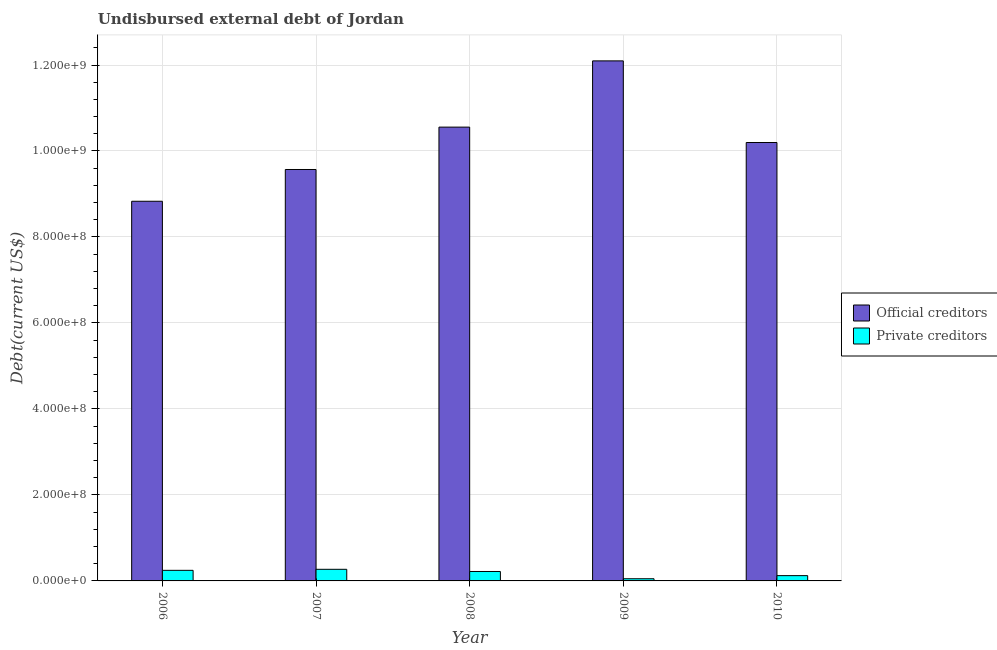How many different coloured bars are there?
Your answer should be compact. 2. How many bars are there on the 3rd tick from the right?
Keep it short and to the point. 2. What is the undisbursed external debt of official creditors in 2009?
Offer a very short reply. 1.21e+09. Across all years, what is the maximum undisbursed external debt of private creditors?
Make the answer very short. 2.70e+07. Across all years, what is the minimum undisbursed external debt of private creditors?
Provide a succinct answer. 5.06e+06. In which year was the undisbursed external debt of private creditors maximum?
Your answer should be very brief. 2007. What is the total undisbursed external debt of private creditors in the graph?
Keep it short and to the point. 9.10e+07. What is the difference between the undisbursed external debt of private creditors in 2008 and that in 2009?
Offer a very short reply. 1.69e+07. What is the difference between the undisbursed external debt of official creditors in 2009 and the undisbursed external debt of private creditors in 2008?
Your answer should be very brief. 1.54e+08. What is the average undisbursed external debt of private creditors per year?
Your answer should be very brief. 1.82e+07. What is the ratio of the undisbursed external debt of official creditors in 2006 to that in 2008?
Provide a short and direct response. 0.84. What is the difference between the highest and the second highest undisbursed external debt of private creditors?
Your answer should be very brief. 2.39e+06. What is the difference between the highest and the lowest undisbursed external debt of private creditors?
Make the answer very short. 2.20e+07. What does the 1st bar from the left in 2008 represents?
Ensure brevity in your answer.  Official creditors. What does the 1st bar from the right in 2006 represents?
Give a very brief answer. Private creditors. How many bars are there?
Your answer should be very brief. 10. What is the difference between two consecutive major ticks on the Y-axis?
Your answer should be compact. 2.00e+08. Are the values on the major ticks of Y-axis written in scientific E-notation?
Provide a short and direct response. Yes. Does the graph contain any zero values?
Your response must be concise. No. Does the graph contain grids?
Ensure brevity in your answer.  Yes. Where does the legend appear in the graph?
Keep it short and to the point. Center right. How many legend labels are there?
Keep it short and to the point. 2. How are the legend labels stacked?
Offer a very short reply. Vertical. What is the title of the graph?
Give a very brief answer. Undisbursed external debt of Jordan. Does "Passenger Transport Items" appear as one of the legend labels in the graph?
Make the answer very short. No. What is the label or title of the Y-axis?
Offer a terse response. Debt(current US$). What is the Debt(current US$) in Official creditors in 2006?
Offer a terse response. 8.83e+08. What is the Debt(current US$) of Private creditors in 2006?
Provide a succinct answer. 2.46e+07. What is the Debt(current US$) of Official creditors in 2007?
Provide a succinct answer. 9.57e+08. What is the Debt(current US$) in Private creditors in 2007?
Offer a very short reply. 2.70e+07. What is the Debt(current US$) in Official creditors in 2008?
Your response must be concise. 1.06e+09. What is the Debt(current US$) of Private creditors in 2008?
Keep it short and to the point. 2.19e+07. What is the Debt(current US$) of Official creditors in 2009?
Keep it short and to the point. 1.21e+09. What is the Debt(current US$) of Private creditors in 2009?
Make the answer very short. 5.06e+06. What is the Debt(current US$) in Official creditors in 2010?
Your response must be concise. 1.02e+09. What is the Debt(current US$) of Private creditors in 2010?
Your answer should be compact. 1.23e+07. Across all years, what is the maximum Debt(current US$) of Official creditors?
Offer a very short reply. 1.21e+09. Across all years, what is the maximum Debt(current US$) of Private creditors?
Provide a succinct answer. 2.70e+07. Across all years, what is the minimum Debt(current US$) of Official creditors?
Offer a terse response. 8.83e+08. Across all years, what is the minimum Debt(current US$) in Private creditors?
Provide a succinct answer. 5.06e+06. What is the total Debt(current US$) of Official creditors in the graph?
Keep it short and to the point. 5.12e+09. What is the total Debt(current US$) of Private creditors in the graph?
Make the answer very short. 9.10e+07. What is the difference between the Debt(current US$) of Official creditors in 2006 and that in 2007?
Give a very brief answer. -7.39e+07. What is the difference between the Debt(current US$) of Private creditors in 2006 and that in 2007?
Offer a very short reply. -2.39e+06. What is the difference between the Debt(current US$) of Official creditors in 2006 and that in 2008?
Your response must be concise. -1.72e+08. What is the difference between the Debt(current US$) in Private creditors in 2006 and that in 2008?
Ensure brevity in your answer.  2.71e+06. What is the difference between the Debt(current US$) in Official creditors in 2006 and that in 2009?
Ensure brevity in your answer.  -3.27e+08. What is the difference between the Debt(current US$) of Private creditors in 2006 and that in 2009?
Keep it short and to the point. 1.96e+07. What is the difference between the Debt(current US$) of Official creditors in 2006 and that in 2010?
Provide a succinct answer. -1.37e+08. What is the difference between the Debt(current US$) of Private creditors in 2006 and that in 2010?
Make the answer very short. 1.23e+07. What is the difference between the Debt(current US$) in Official creditors in 2007 and that in 2008?
Offer a terse response. -9.86e+07. What is the difference between the Debt(current US$) of Private creditors in 2007 and that in 2008?
Your answer should be compact. 5.10e+06. What is the difference between the Debt(current US$) of Official creditors in 2007 and that in 2009?
Ensure brevity in your answer.  -2.53e+08. What is the difference between the Debt(current US$) of Private creditors in 2007 and that in 2009?
Keep it short and to the point. 2.20e+07. What is the difference between the Debt(current US$) in Official creditors in 2007 and that in 2010?
Ensure brevity in your answer.  -6.27e+07. What is the difference between the Debt(current US$) in Private creditors in 2007 and that in 2010?
Offer a very short reply. 1.47e+07. What is the difference between the Debt(current US$) in Official creditors in 2008 and that in 2009?
Ensure brevity in your answer.  -1.54e+08. What is the difference between the Debt(current US$) in Private creditors in 2008 and that in 2009?
Give a very brief answer. 1.69e+07. What is the difference between the Debt(current US$) of Official creditors in 2008 and that in 2010?
Make the answer very short. 3.58e+07. What is the difference between the Debt(current US$) of Private creditors in 2008 and that in 2010?
Give a very brief answer. 9.62e+06. What is the difference between the Debt(current US$) in Official creditors in 2009 and that in 2010?
Your response must be concise. 1.90e+08. What is the difference between the Debt(current US$) of Private creditors in 2009 and that in 2010?
Give a very brief answer. -7.24e+06. What is the difference between the Debt(current US$) of Official creditors in 2006 and the Debt(current US$) of Private creditors in 2007?
Give a very brief answer. 8.56e+08. What is the difference between the Debt(current US$) in Official creditors in 2006 and the Debt(current US$) in Private creditors in 2008?
Give a very brief answer. 8.61e+08. What is the difference between the Debt(current US$) of Official creditors in 2006 and the Debt(current US$) of Private creditors in 2009?
Your response must be concise. 8.78e+08. What is the difference between the Debt(current US$) in Official creditors in 2006 and the Debt(current US$) in Private creditors in 2010?
Make the answer very short. 8.71e+08. What is the difference between the Debt(current US$) in Official creditors in 2007 and the Debt(current US$) in Private creditors in 2008?
Your answer should be compact. 9.35e+08. What is the difference between the Debt(current US$) of Official creditors in 2007 and the Debt(current US$) of Private creditors in 2009?
Your answer should be very brief. 9.52e+08. What is the difference between the Debt(current US$) of Official creditors in 2007 and the Debt(current US$) of Private creditors in 2010?
Your answer should be compact. 9.45e+08. What is the difference between the Debt(current US$) in Official creditors in 2008 and the Debt(current US$) in Private creditors in 2009?
Provide a short and direct response. 1.05e+09. What is the difference between the Debt(current US$) of Official creditors in 2008 and the Debt(current US$) of Private creditors in 2010?
Your answer should be very brief. 1.04e+09. What is the difference between the Debt(current US$) in Official creditors in 2009 and the Debt(current US$) in Private creditors in 2010?
Offer a terse response. 1.20e+09. What is the average Debt(current US$) of Official creditors per year?
Ensure brevity in your answer.  1.02e+09. What is the average Debt(current US$) of Private creditors per year?
Provide a succinct answer. 1.82e+07. In the year 2006, what is the difference between the Debt(current US$) of Official creditors and Debt(current US$) of Private creditors?
Ensure brevity in your answer.  8.58e+08. In the year 2007, what is the difference between the Debt(current US$) in Official creditors and Debt(current US$) in Private creditors?
Provide a succinct answer. 9.30e+08. In the year 2008, what is the difference between the Debt(current US$) in Official creditors and Debt(current US$) in Private creditors?
Give a very brief answer. 1.03e+09. In the year 2009, what is the difference between the Debt(current US$) of Official creditors and Debt(current US$) of Private creditors?
Make the answer very short. 1.20e+09. In the year 2010, what is the difference between the Debt(current US$) of Official creditors and Debt(current US$) of Private creditors?
Keep it short and to the point. 1.01e+09. What is the ratio of the Debt(current US$) of Official creditors in 2006 to that in 2007?
Keep it short and to the point. 0.92. What is the ratio of the Debt(current US$) in Private creditors in 2006 to that in 2007?
Provide a succinct answer. 0.91. What is the ratio of the Debt(current US$) in Official creditors in 2006 to that in 2008?
Offer a very short reply. 0.84. What is the ratio of the Debt(current US$) in Private creditors in 2006 to that in 2008?
Give a very brief answer. 1.12. What is the ratio of the Debt(current US$) in Official creditors in 2006 to that in 2009?
Provide a short and direct response. 0.73. What is the ratio of the Debt(current US$) of Private creditors in 2006 to that in 2009?
Provide a succinct answer. 4.87. What is the ratio of the Debt(current US$) in Official creditors in 2006 to that in 2010?
Your answer should be compact. 0.87. What is the ratio of the Debt(current US$) in Private creditors in 2006 to that in 2010?
Offer a terse response. 2. What is the ratio of the Debt(current US$) in Official creditors in 2007 to that in 2008?
Offer a very short reply. 0.91. What is the ratio of the Debt(current US$) in Private creditors in 2007 to that in 2008?
Keep it short and to the point. 1.23. What is the ratio of the Debt(current US$) in Official creditors in 2007 to that in 2009?
Your response must be concise. 0.79. What is the ratio of the Debt(current US$) of Private creditors in 2007 to that in 2009?
Provide a succinct answer. 5.34. What is the ratio of the Debt(current US$) in Official creditors in 2007 to that in 2010?
Give a very brief answer. 0.94. What is the ratio of the Debt(current US$) in Private creditors in 2007 to that in 2010?
Offer a terse response. 2.2. What is the ratio of the Debt(current US$) of Official creditors in 2008 to that in 2009?
Your response must be concise. 0.87. What is the ratio of the Debt(current US$) in Private creditors in 2008 to that in 2009?
Provide a short and direct response. 4.33. What is the ratio of the Debt(current US$) of Official creditors in 2008 to that in 2010?
Your answer should be compact. 1.04. What is the ratio of the Debt(current US$) in Private creditors in 2008 to that in 2010?
Keep it short and to the point. 1.78. What is the ratio of the Debt(current US$) of Official creditors in 2009 to that in 2010?
Your response must be concise. 1.19. What is the ratio of the Debt(current US$) of Private creditors in 2009 to that in 2010?
Keep it short and to the point. 0.41. What is the difference between the highest and the second highest Debt(current US$) in Official creditors?
Provide a succinct answer. 1.54e+08. What is the difference between the highest and the second highest Debt(current US$) of Private creditors?
Ensure brevity in your answer.  2.39e+06. What is the difference between the highest and the lowest Debt(current US$) in Official creditors?
Provide a short and direct response. 3.27e+08. What is the difference between the highest and the lowest Debt(current US$) in Private creditors?
Your response must be concise. 2.20e+07. 